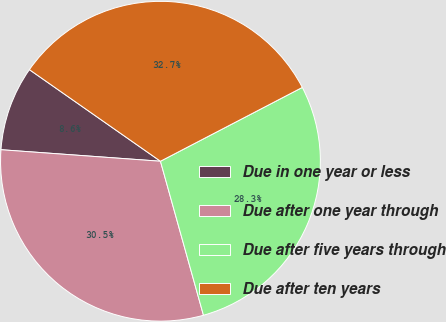Convert chart to OTSL. <chart><loc_0><loc_0><loc_500><loc_500><pie_chart><fcel>Due in one year or less<fcel>Due after one year through<fcel>Due after five years through<fcel>Due after ten years<nl><fcel>8.56%<fcel>30.48%<fcel>28.3%<fcel>32.65%<nl></chart> 